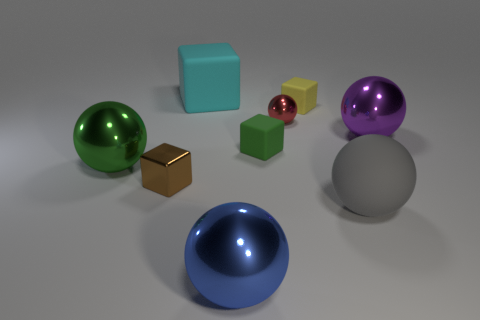How many other tiny things have the same shape as the yellow rubber thing?
Your response must be concise. 2. What number of objects are large purple metallic things or metal things on the right side of the small metal cube?
Your response must be concise. 3. What size is the metallic ball that is in front of the small red metallic thing and behind the green sphere?
Ensure brevity in your answer.  Large. There is a tiny metal ball; are there any green balls to the left of it?
Make the answer very short. Yes. There is a tiny rubber block behind the tiny green matte block; are there any shiny balls that are on the left side of it?
Your response must be concise. Yes. Are there the same number of tiny metal cubes that are to the right of the large gray object and big cyan cubes that are on the right side of the big cyan rubber cube?
Offer a very short reply. Yes. What color is the tiny cube that is made of the same material as the large blue thing?
Make the answer very short. Brown. Are there any large green objects that have the same material as the small red sphere?
Offer a terse response. Yes. How many things are either green balls or red metallic spheres?
Give a very brief answer. 2. Is the small green thing made of the same material as the tiny cube that is to the right of the small sphere?
Offer a terse response. Yes. 